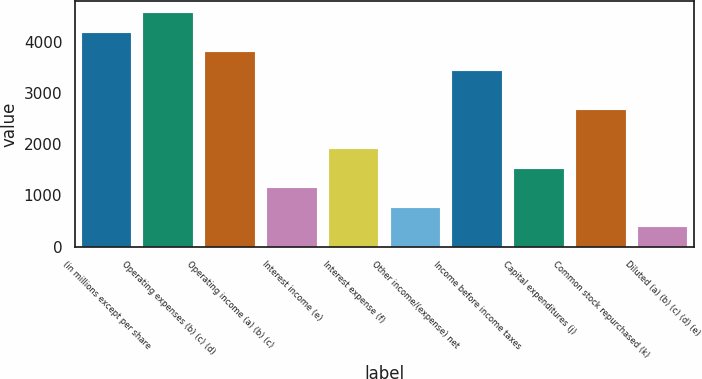Convert chart. <chart><loc_0><loc_0><loc_500><loc_500><bar_chart><fcel>(in millions except per share<fcel>Operating expenses (b) (c) (d)<fcel>Operating income (a) (b) (c)<fcel>Interest income (e)<fcel>Interest expense (f)<fcel>Other income/(expense) net<fcel>Income before income taxes<fcel>Capital expenditures (j)<fcel>Common stock repurchased (k)<fcel>Diluted (a) (b) (c) (d) (e)<nl><fcel>4180.94<fcel>4561.02<fcel>3800.86<fcel>1140.3<fcel>1900.46<fcel>760.22<fcel>3420.78<fcel>1520.38<fcel>2660.62<fcel>380.14<nl></chart> 